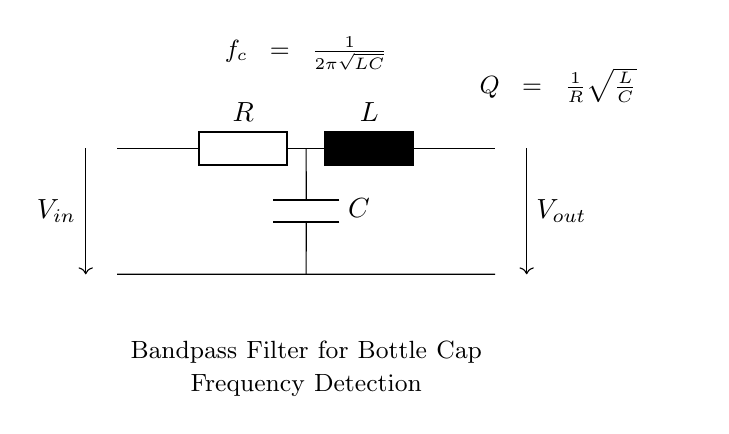What are the components of this circuit? The circuit contains a resistor, an inductor, and a capacitor, which are clearly labeled as R, L, and C respectively.
Answer: Resistor, Inductor, Capacitor What is the function of this circuit? The circuit is designed as a bandpass filter, which is indicated by the label "Bandpass Filter for Bottle Cap Frequency Detection". Its purpose is to allow specific frequencies to pass while blocking others.
Answer: Bandpass filter What is the central frequency formula shown in the circuit? The formula displayed in the circuit is for the central frequency, given by "f_c = 1/(2π√(LC))", which indicates how the frequency is determined by the values of L and C.
Answer: f_c = 1/(2π√(LC)) What is the quality factor formula in this circuit? The quality factor formula shown in the circuit is "Q = (1/R)√(L/C)", which describes how the quality factor is influenced by the resistance, inductance, and capacitance values.
Answer: Q = (1/R)√(L/C) What does the input voltage represent in this circuit? The input voltage, labeled as "V_in", is the voltage that drives the circuit, providing the signal that the filter will process to detect specific frequencies.
Answer: V_in How do the resistor, inductor, and capacitor affect frequency response? The resistor affects the damping of the circuit, the inductor affects the inductive reactance, and the capacitor affects the capacitive reactance; together they define the frequency response of the bandpass filter.
Answer: They define frequency response 